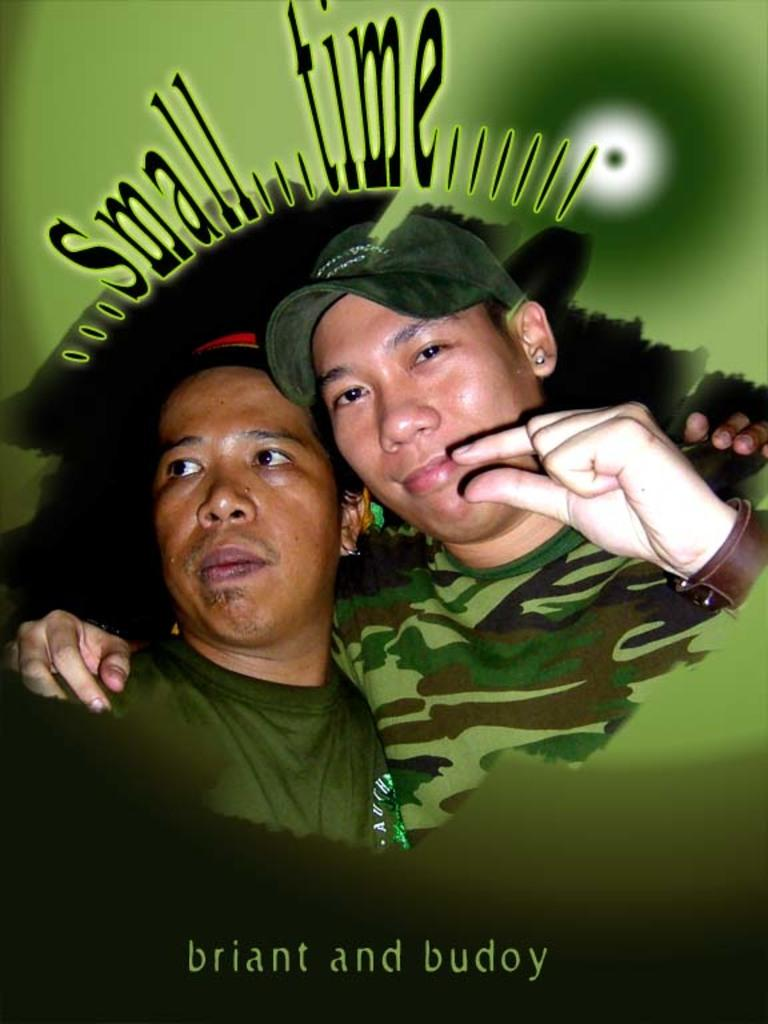How many people are in the image? There are two persons in the image. What can be seen at the top of the image? There is text at the top of the image. What can be seen at the bottom of the image? There is text at the bottom of the image. What type of attack is being carried out by the fireman in the image? There is no fireman or attack present in the image. What belief system is represented by the text in the image? The provided facts do not mention any specific belief system or text content, so it cannot be determined from the image. 